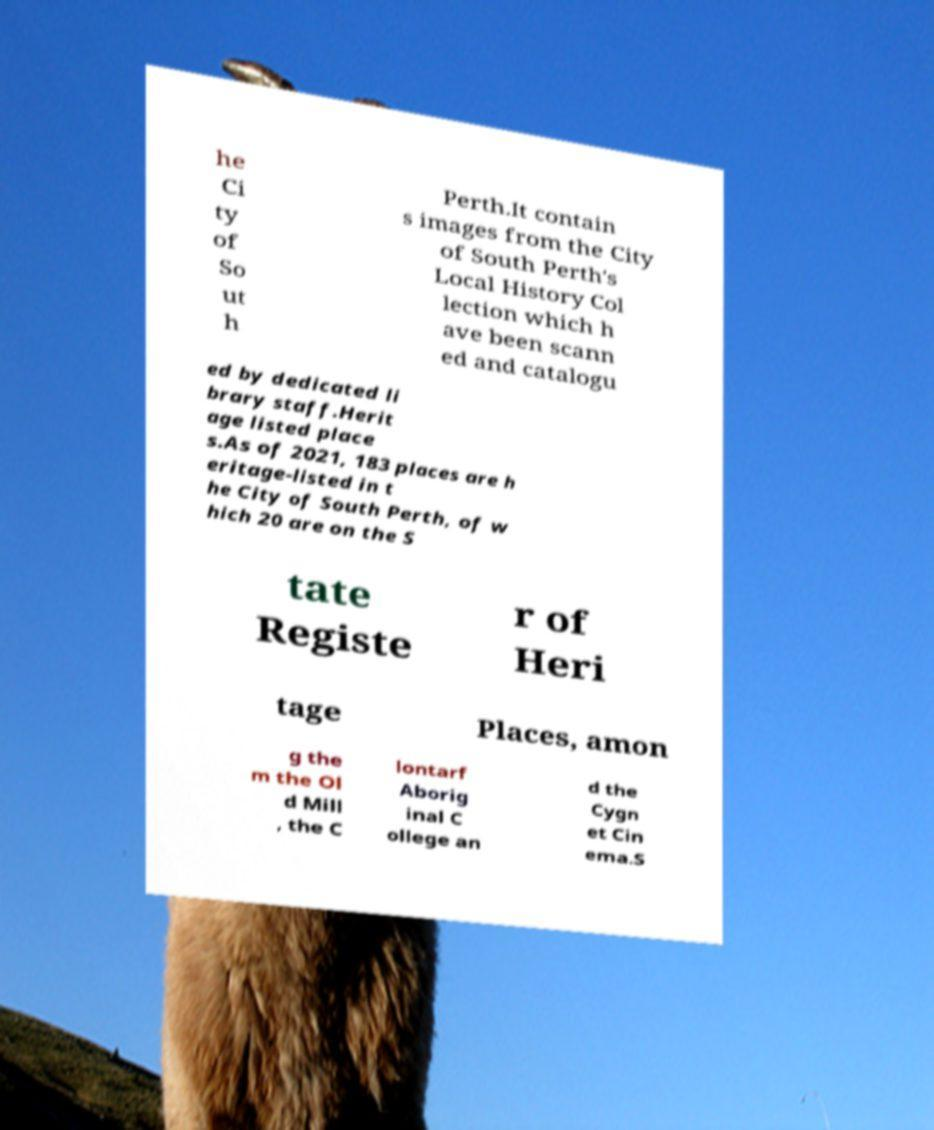I need the written content from this picture converted into text. Can you do that? he Ci ty of So ut h Perth.It contain s images from the City of South Perth's Local History Col lection which h ave been scann ed and catalogu ed by dedicated li brary staff.Herit age listed place s.As of 2021, 183 places are h eritage-listed in t he City of South Perth, of w hich 20 are on the S tate Registe r of Heri tage Places, amon g the m the Ol d Mill , the C lontarf Aborig inal C ollege an d the Cygn et Cin ema.S 